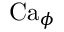Convert formula to latex. <formula><loc_0><loc_0><loc_500><loc_500>C a _ { \phi }</formula> 